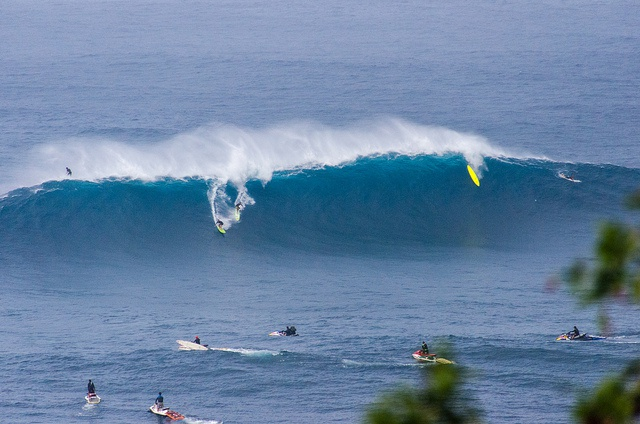Describe the objects in this image and their specific colors. I can see boat in darkgray, black, gray, and maroon tones, boat in darkgray, lightgray, and gray tones, boat in darkgray, gray, lightgray, and violet tones, surfboard in darkgray, gray, lightgray, and violet tones, and boat in darkgray, lightgray, gray, and beige tones in this image. 